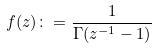Convert formula to latex. <formula><loc_0><loc_0><loc_500><loc_500>f ( z ) \colon = \frac { 1 } { \Gamma ( z ^ { - 1 } - 1 ) }</formula> 